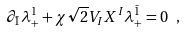Convert formula to latex. <formula><loc_0><loc_0><loc_500><loc_500>\partial _ { \bar { 1 } } \lambda _ { + } ^ { 1 } + \chi \sqrt { 2 } V _ { I } X ^ { I } \lambda _ { + } ^ { \bar { 1 } } = 0 \ ,</formula> 